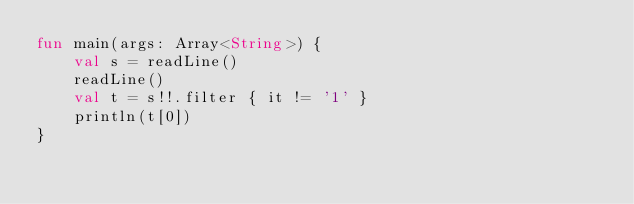Convert code to text. <code><loc_0><loc_0><loc_500><loc_500><_Kotlin_>fun main(args: Array<String>) {
    val s = readLine()
    readLine()
    val t = s!!.filter { it != '1' }
    println(t[0])
}
</code> 